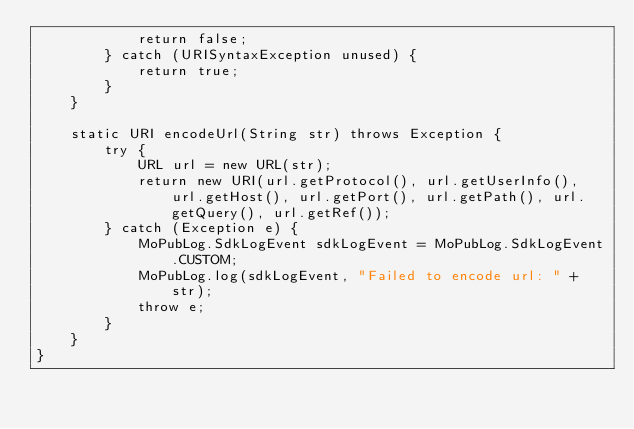Convert code to text. <code><loc_0><loc_0><loc_500><loc_500><_Java_>            return false;
        } catch (URISyntaxException unused) {
            return true;
        }
    }

    static URI encodeUrl(String str) throws Exception {
        try {
            URL url = new URL(str);
            return new URI(url.getProtocol(), url.getUserInfo(), url.getHost(), url.getPort(), url.getPath(), url.getQuery(), url.getRef());
        } catch (Exception e) {
            MoPubLog.SdkLogEvent sdkLogEvent = MoPubLog.SdkLogEvent.CUSTOM;
            MoPubLog.log(sdkLogEvent, "Failed to encode url: " + str);
            throw e;
        }
    }
}
</code> 